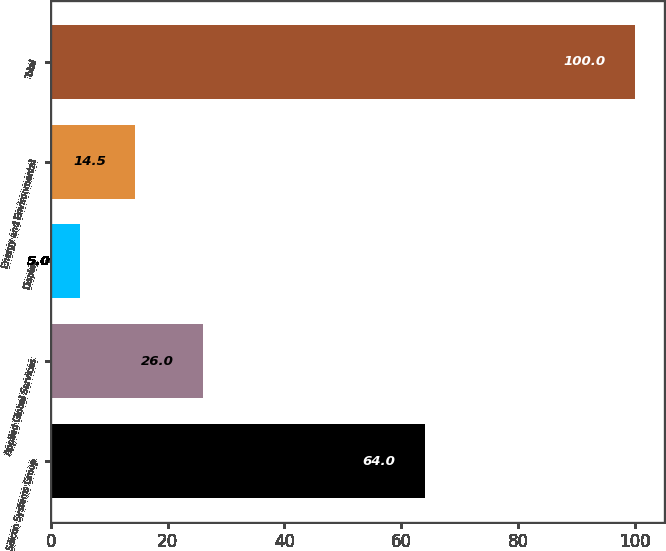Convert chart. <chart><loc_0><loc_0><loc_500><loc_500><bar_chart><fcel>Silicon Systems Group<fcel>Applied Global Services<fcel>Display<fcel>Energy and Environmental<fcel>Total<nl><fcel>64<fcel>26<fcel>5<fcel>14.5<fcel>100<nl></chart> 